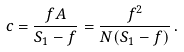Convert formula to latex. <formula><loc_0><loc_0><loc_500><loc_500>c = { \frac { f A } { S _ { 1 } - f } } = { \frac { f ^ { 2 } } { N ( S _ { 1 } - f ) } } \, .</formula> 